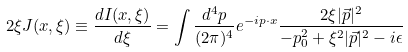<formula> <loc_0><loc_0><loc_500><loc_500>2 \xi J ( x , \xi ) \equiv \frac { d I ( x , \xi ) } { d \xi } = \int \frac { d ^ { 4 } p } { ( 2 \pi ) ^ { 4 } } e ^ { - i p \cdot x } \frac { 2 \xi | \vec { p } | ^ { 2 } } { - p _ { 0 } ^ { 2 } + \xi ^ { 2 } | \vec { p } | ^ { 2 } - i \epsilon }</formula> 